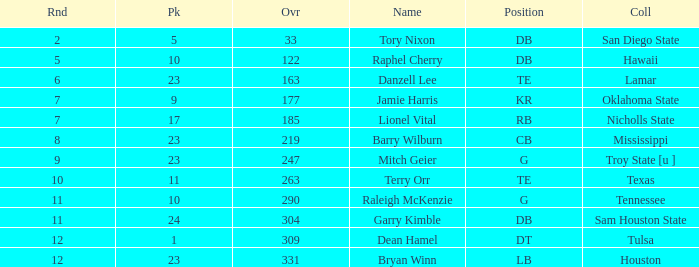How many picks possess an overall below 304, g as their position, and a round under 11? 1.0. 